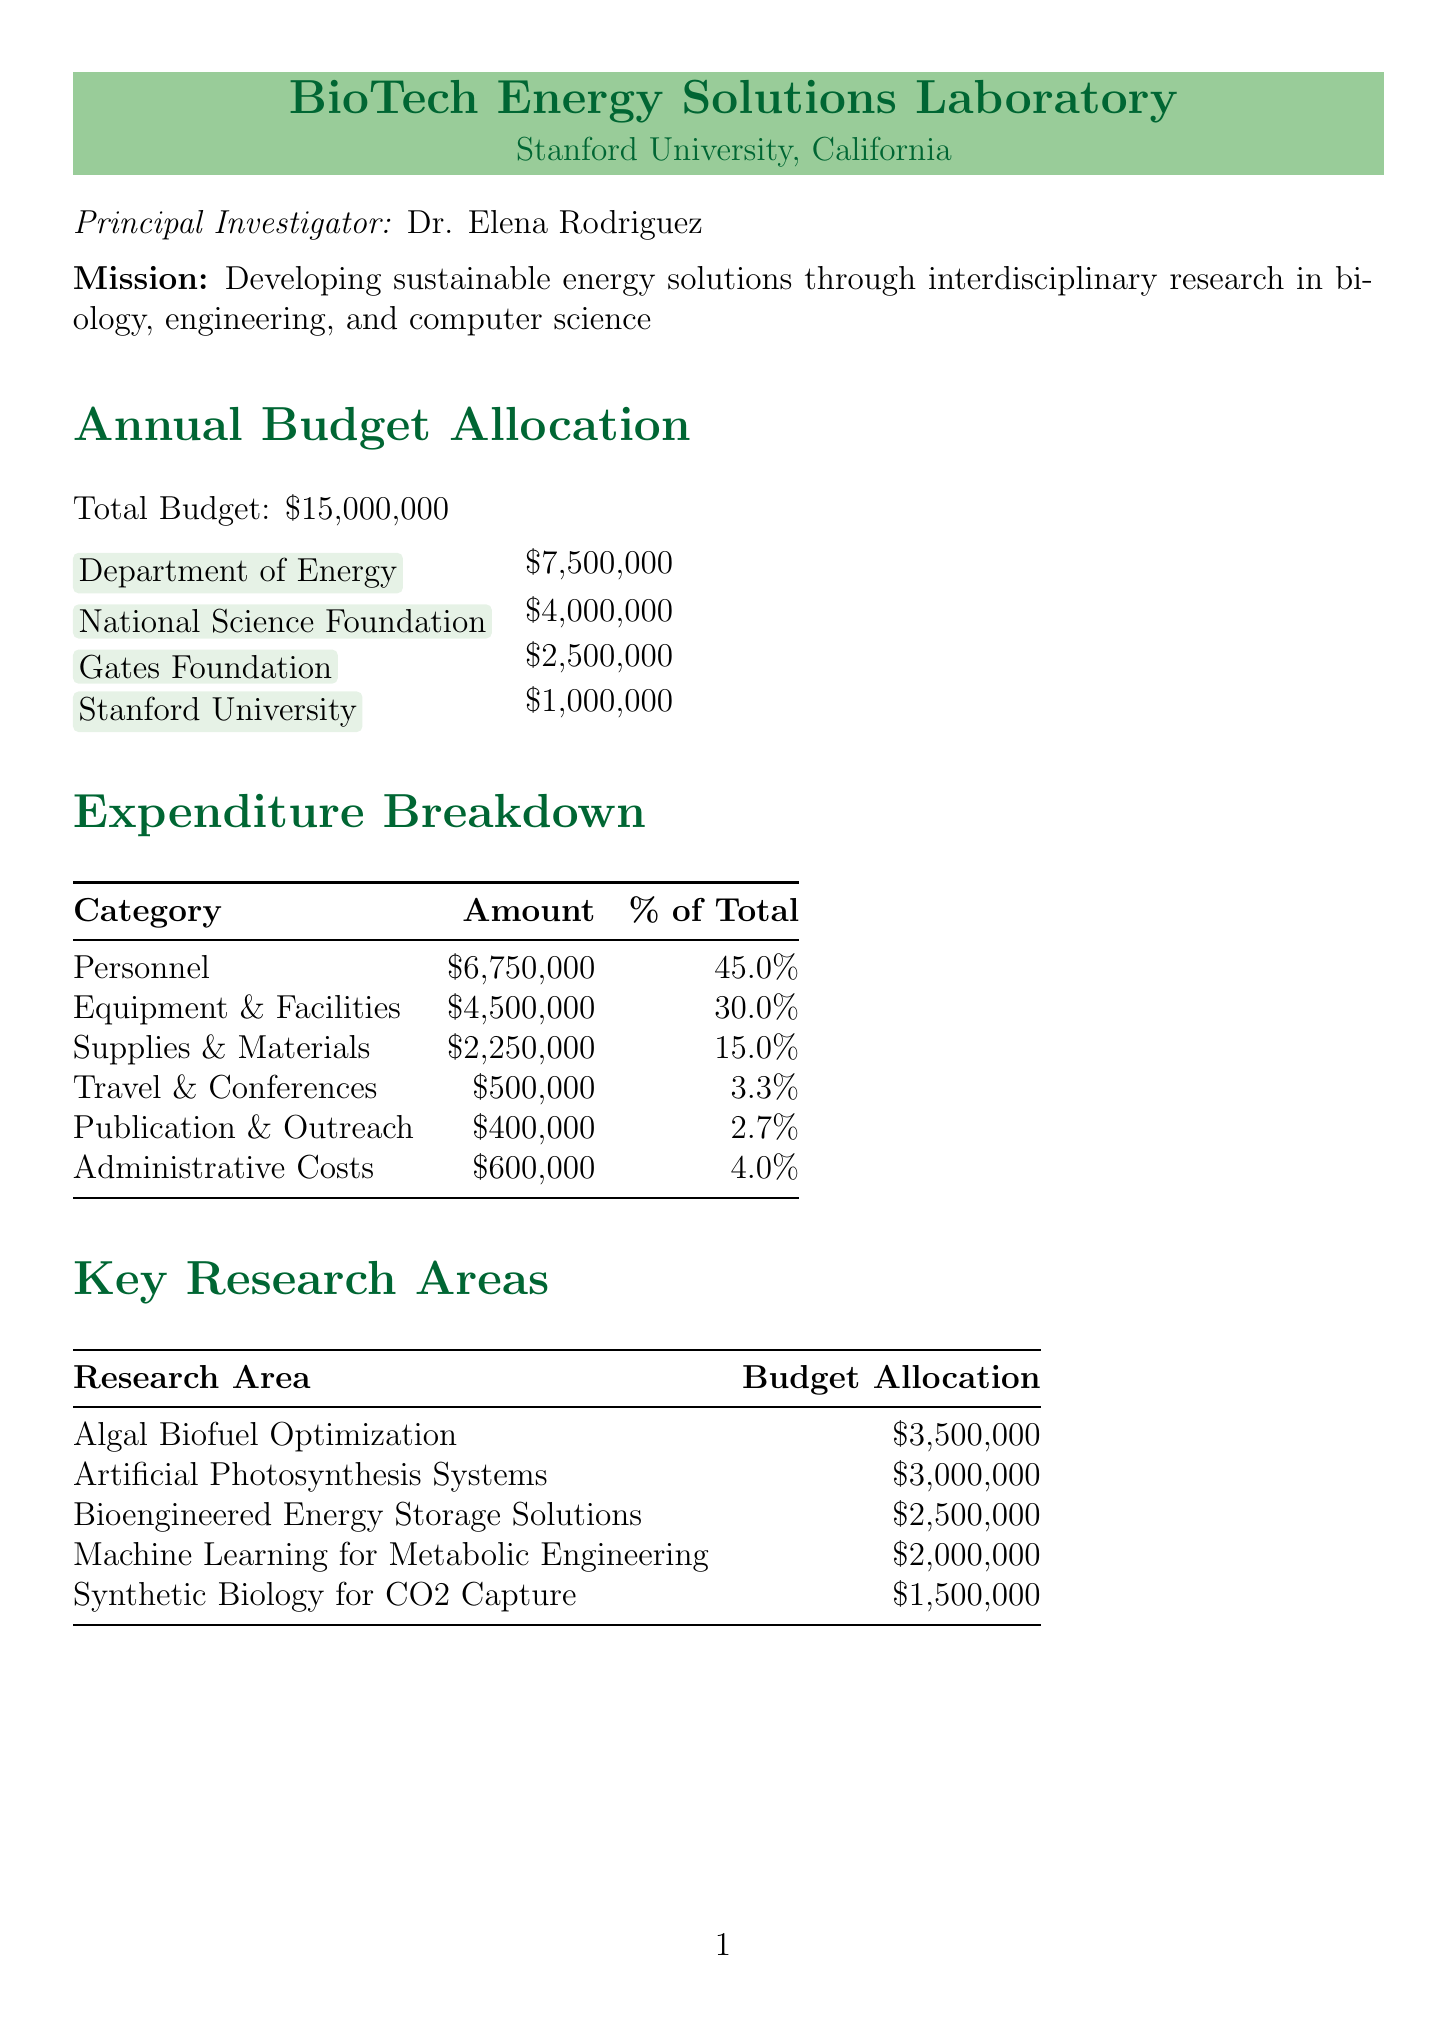What is the name of the laboratory? The name of the laboratory is specified in the document as "BioTech Energy Solutions Laboratory."
Answer: BioTech Energy Solutions Laboratory Who is the principal investigator? The document lists Dr. Elena Rodriguez as the principal investigator of the laboratory.
Answer: Dr. Elena Rodriguez What is the total budget allocation? The document states the total budget allocation for the laboratory as fifteen million dollars.
Answer: $15,000,000 What percentage of the budget is allocated to personnel? The document details that personnel expenditures constitute forty-five percent of the total budget allocation.
Answer: 45.0% How much funding comes from the National Science Foundation? The funding amount from the National Science Foundation is explicitly stated as four million dollars.
Answer: $4,000,000 Which research area has the highest budget allocation? The document identifies "Algal Biofuel Optimization" as the research area with the highest budget allocation at three million five hundred thousand dollars.
Answer: $3,500,000 How many patents does the performance metric target set? According to the performance metrics, the target for patent applications is ten.
Answer: 10 What is the budget allocated for the project with MIT? The budget allocated for the project with the Massachusetts Institute of Technology is listed as seven hundred fifty thousand dollars.
Answer: $750,000 What is the target number of public outreach events? The document mentions the target for public outreach events as fifteen.
Answer: 15 